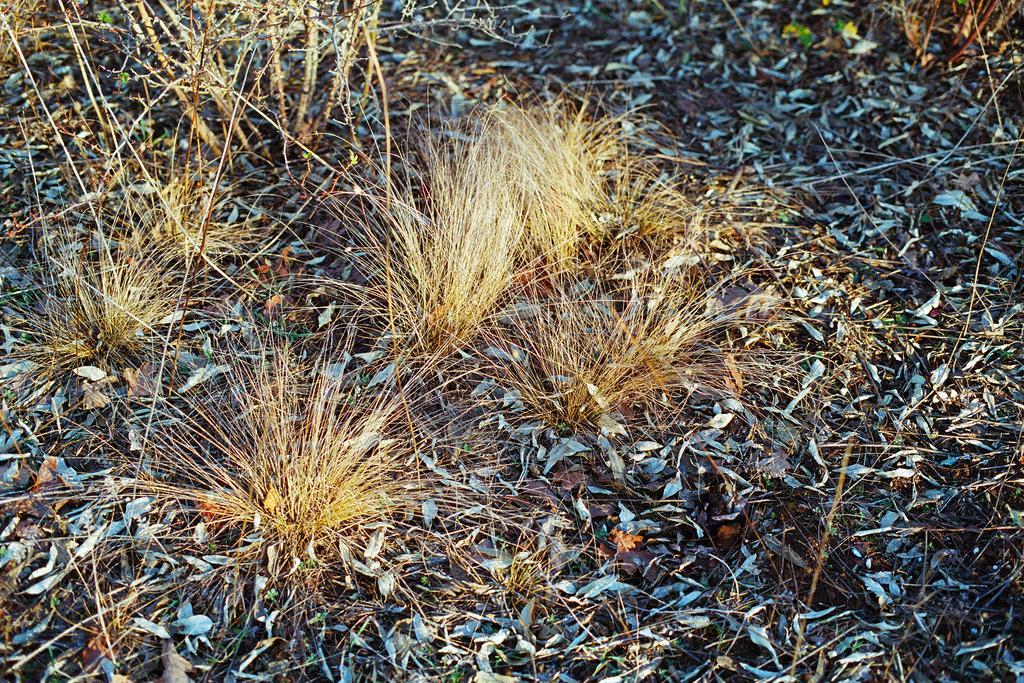Can you describe this image briefly? This image is taken outdoors. In this image there is a ground with grass on it and there are many dry leaves on the ground. There are a few plants with stems. 